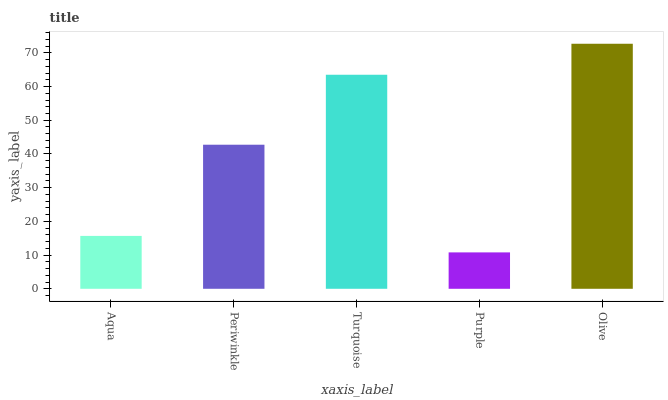Is Periwinkle the minimum?
Answer yes or no. No. Is Periwinkle the maximum?
Answer yes or no. No. Is Periwinkle greater than Aqua?
Answer yes or no. Yes. Is Aqua less than Periwinkle?
Answer yes or no. Yes. Is Aqua greater than Periwinkle?
Answer yes or no. No. Is Periwinkle less than Aqua?
Answer yes or no. No. Is Periwinkle the high median?
Answer yes or no. Yes. Is Periwinkle the low median?
Answer yes or no. Yes. Is Aqua the high median?
Answer yes or no. No. Is Aqua the low median?
Answer yes or no. No. 